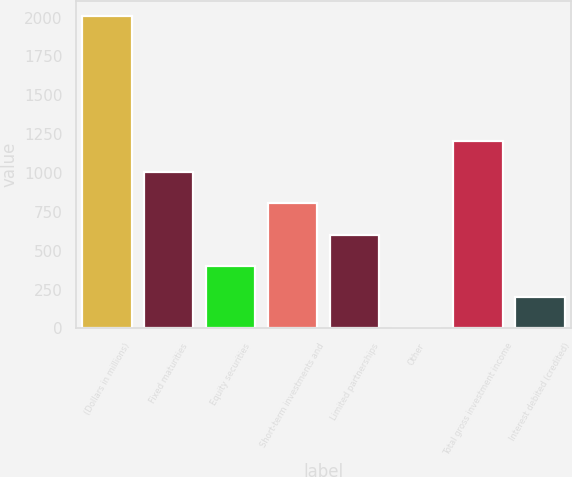Convert chart. <chart><loc_0><loc_0><loc_500><loc_500><bar_chart><fcel>(Dollars in millions)<fcel>Fixed maturities<fcel>Equity securities<fcel>Short-term investments and<fcel>Limited partnerships<fcel>Other<fcel>Total gross investment income<fcel>Interest debited (credited)<nl><fcel>2008<fcel>1005.15<fcel>403.44<fcel>804.58<fcel>604.01<fcel>2.3<fcel>1205.72<fcel>202.87<nl></chart> 